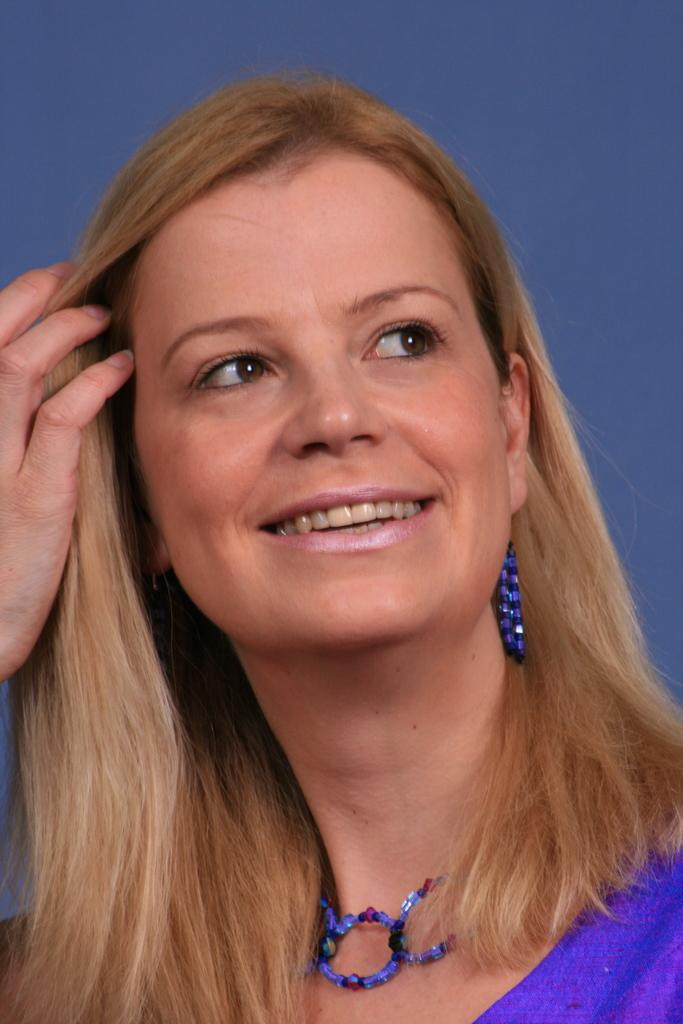What is the main subject of the image? There is a person in the image. What color is the background of the image? The background of the image is blue. Can you play the guitar riddle on the brick in the image? There is no guitar, riddle, or brick present in the image. 